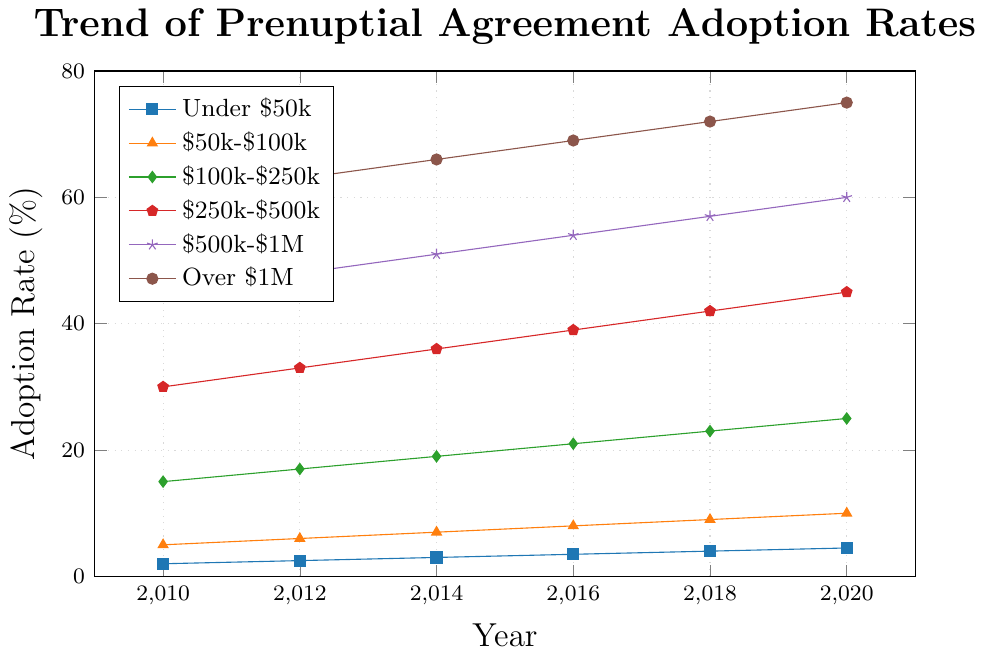What was the adoption rate for the income bracket of $250k-$500k in 2014? Look at the graph and find the line representing the $250k-$500k income bracket (usually color-coded). Check the y-axis value for the year 2014. The adoption rate is marked as 36%.
Answer: 36% Which income bracket saw the highest adoption rate in 2020? Identify the highest point on the graph for the year 2020 by comparing the y-values of all lines. The line representing "Over $1M" reaches 75%, the highest rate for that year.
Answer: Over $1M How much did the adoption rate for the $100k-$250k income bracket increase from 2010 to 2016? Check the adoption rate for this income bracket in 2010 and 2016 from the graph. The values are 15% and 21%, respectively. Calculate the difference: 21% - 15% = 6%.
Answer: 6% Which income bracket experienced the largest percentage point increase between 2010 and 2020? Compare the increases over time for all income brackets. The "Over $1M" bracket went from 60% in 2010 to 75% in 2020, an increase of 15 percentage points, which is the largest among the brackets.
Answer: Over $1M What is the average adoption rate for the $500k-$1M income bracket over the years presented? Add the adoption rates for all years (2010: 45%, 2012: 48%, 2014: 51%, 2016: 54%, 2018: 57%, 2020: 60%) and divide by the number of years: (45 + 48 + 51 + 54 + 57 + 60) / 6 = 52.5%.
Answer: 52.5% Compare the adoption rates in 2018 between the income brackets of Under $50k and $50k-$100k. Which one is higher and by how much? Find the adoption rates in 2018 for both brackets from the graph. Under $50k is at 4%, and $50k-$100k is at 9%. The difference is 9% - 4% = 5%. Thus, $50k-$100k is higher by 5%.
Answer: $50k-$100k, by 5% What trend can be observed for the adoption rates of all income brackets from 2010 to 2020? Observe the overall direction of all lines from 2010 to 2020. All lines are trending upwards, indicating an increase in adoption rates across all income brackets over the decade.
Answer: Increasing trend In which year did the $250k-$500k income bracket exceed the 40% adoption rate? Find the point where the $250k-$500k line crosses the 40% mark. This occurs between 2016 and 2018. By checking, it exceeded 40% in 2018.
Answer: 2018 Considering the under $50k income bracket, what was the average annual increase in adoption rate from 2010 to 2020? Calculate the total increase from 2010 (2%) to 2020 (4.5%), which is 4.5% - 2% = 2.5%. Divide this by the number of years (2020 - 2010 = 10 years): 2.5% / 10 = 0.25% per year.
Answer: 0.25% per year 